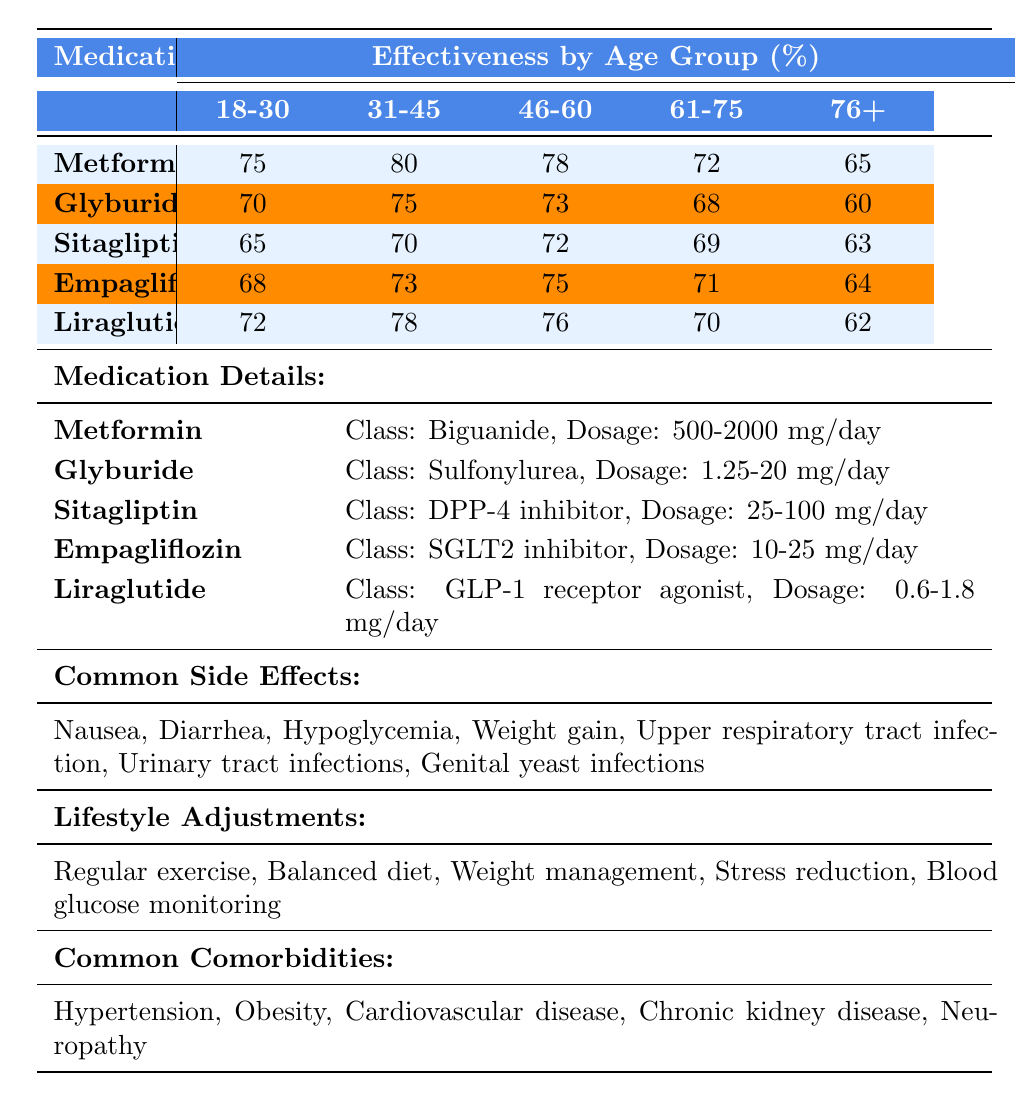What is the effectiveness of Metformin for the age group 31-45? According to the table, the effectiveness of Metformin for the age group 31-45 is 80%.
Answer: 80% Which medication has the highest effectiveness in the age group 18-30? The effectiveness of Metformin in the age group 18-30 is 75%, and Glyburide has 70%. Comparing these, Metformin has the highest effectiveness of 75%.
Answer: Metformin What are the common side effects of Glyburide? The table lists the common side effects of Glyburide as Hypoglycemia and Weight gain.
Answer: Hypoglycemia, Weight gain What is the average effectiveness of Sitagliptin across all age groups? The effectiveness of Sitagliptin is 65%, 70%, 72%, 69%, and 63%. Summing them gives 65 + 70 + 72 + 69 + 63 = 339. Dividing by 5 results in 339/5 = 67.8.
Answer: 67.8% Does the effectiveness of Empagliflozin decrease with age? The effectiveness of Empagliflozin is 68%, 73%, 75%, 71%, and 64%, which shows a decreasing trend from the age group 31-45 to 76+. Thus, yes.
Answer: Yes Which medication is the least effective for those aged 76 and above? The effectiveness for the age group 76+ is 65% for Metformin, 60% for Glyburide, 63% for Sitagliptin, 64% for Empagliflozin, and 62% for Liraglutide. Glyburide has the lowest effectiveness at 60%.
Answer: Glyburide What is the dosage range for Liraglutide? According to the table, the daily dosage range for Liraglutide is 0.6-1.8 mg.
Answer: 0.6-1.8 mg What is the effectiveness difference between Metformin and Liraglutide for the 46-60 age group? The effectiveness of Metformin for the 46-60 age group is 78%, and for Liraglutide, it is 76%. The difference is 78 - 76 = 2%.
Answer: 2% Is Liraglutide more effective than Sitagliptin in the age group 61-75? The effectiveness of Liraglutide for the age group 61-75 is 70%, while Sitagliptin's effectiveness is 69%. Since 70% is greater than 69%, Liraglutide is more effective.
Answer: Yes What medications show effectiveness for the age group 76+? For the age group 76+, the medications and their effectiveness are Metformin (65%), Glyburide (60%), Sitagliptin (63%), Empagliflozin (64%), and Liraglutide (62%).
Answer: All listed medications Calculate the average effectiveness of Metformin and Empagliflozin in the age group 61-75. The effectiveness of Metformin in 61-75 is 72%, and for Empagliflozin, it is 71%. Adding these gives 72 + 71 = 143. Dividing by 2 yields an average of 143/2 = 71.5%.
Answer: 71.5% 